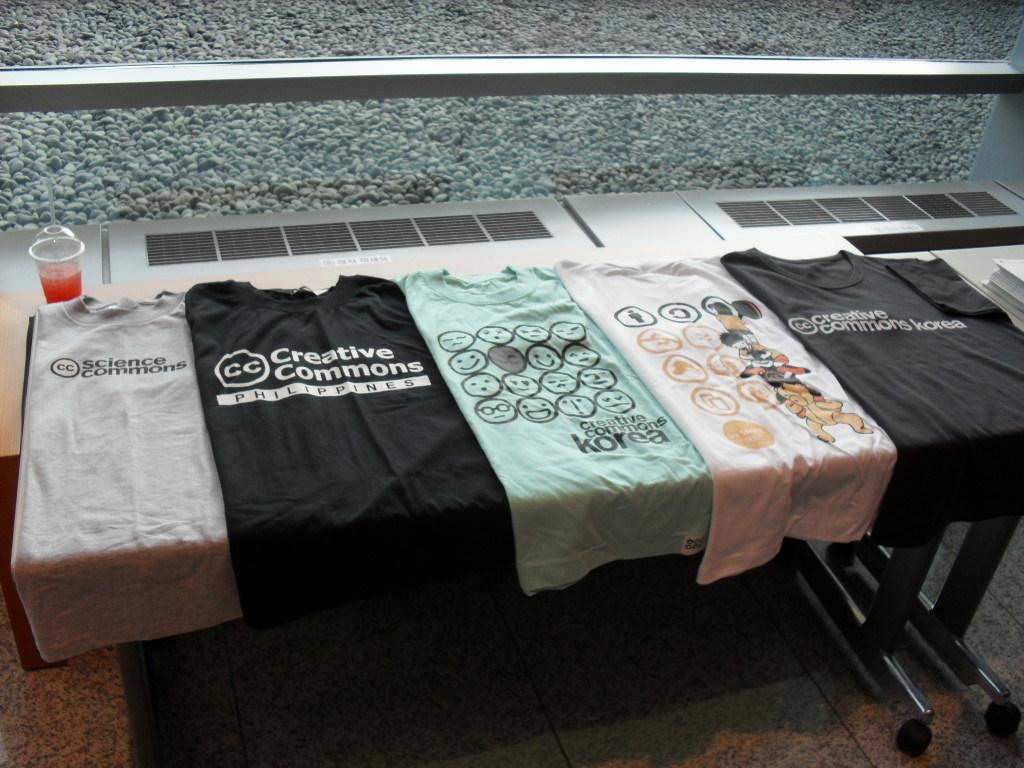Can you describe this image briefly? In this image there are a few clothes arranged on a table and there is a drink. In the background there is a surface of the rocks. 